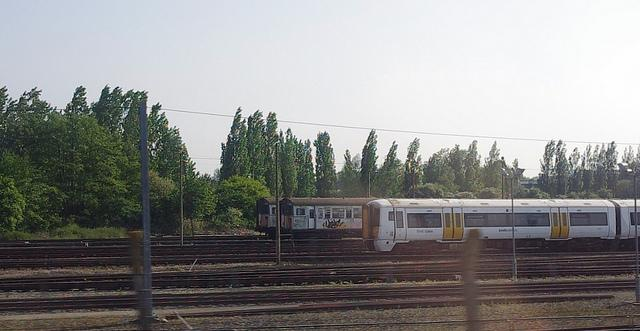During which time of the year are these trains operating?

Choices:
A) winter
B) fall
C) summer
D) spring summer 